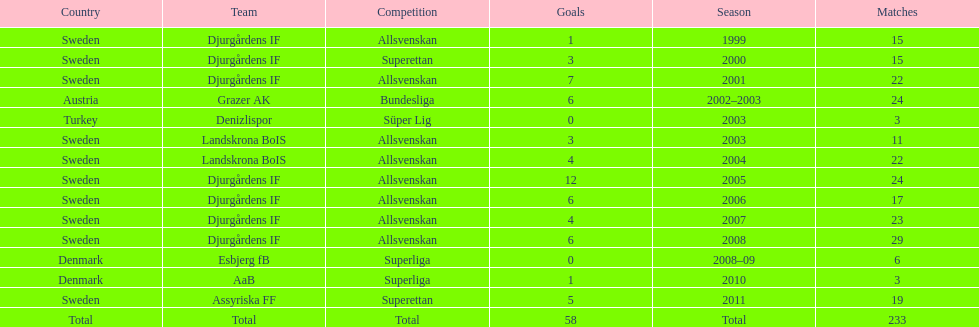What country is team djurgårdens if not from? Sweden. 